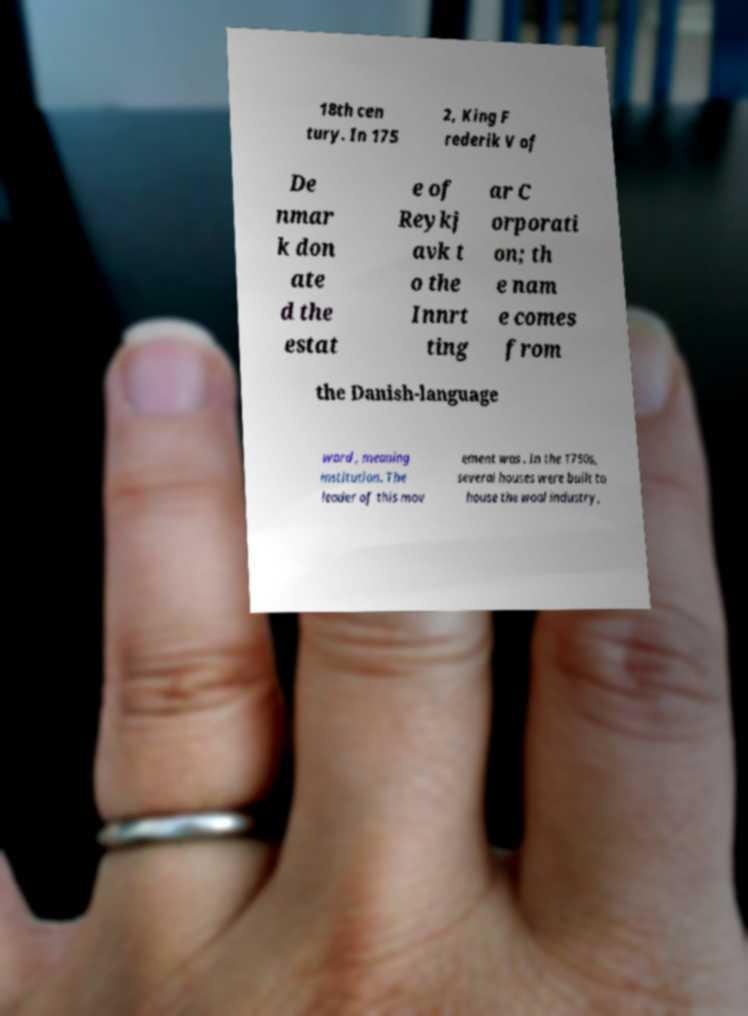Could you extract and type out the text from this image? 18th cen tury. In 175 2, King F rederik V of De nmar k don ate d the estat e of Reykj avk t o the Innrt ting ar C orporati on; th e nam e comes from the Danish-language word , meaning institution. The leader of this mov ement was . In the 1750s, several houses were built to house the wool industry, 